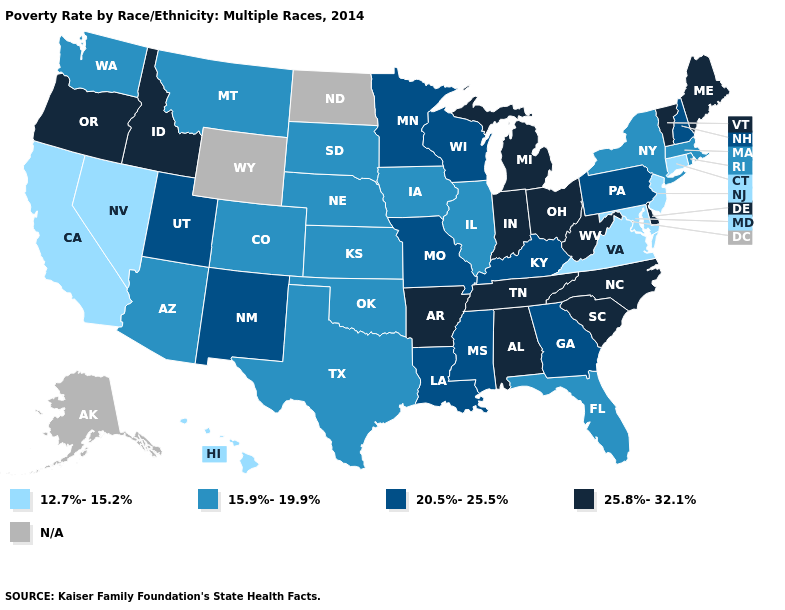Is the legend a continuous bar?
Quick response, please. No. Which states have the lowest value in the USA?
Quick response, please. California, Connecticut, Hawaii, Maryland, Nevada, New Jersey, Virginia. Name the states that have a value in the range 25.8%-32.1%?
Short answer required. Alabama, Arkansas, Delaware, Idaho, Indiana, Maine, Michigan, North Carolina, Ohio, Oregon, South Carolina, Tennessee, Vermont, West Virginia. Name the states that have a value in the range 12.7%-15.2%?
Keep it brief. California, Connecticut, Hawaii, Maryland, Nevada, New Jersey, Virginia. Does Texas have the highest value in the South?
Give a very brief answer. No. Does Oregon have the highest value in the USA?
Quick response, please. Yes. What is the value of Ohio?
Short answer required. 25.8%-32.1%. Does the first symbol in the legend represent the smallest category?
Write a very short answer. Yes. What is the value of Georgia?
Be succinct. 20.5%-25.5%. Name the states that have a value in the range N/A?
Keep it brief. Alaska, North Dakota, Wyoming. Among the states that border Connecticut , which have the lowest value?
Write a very short answer. Massachusetts, New York, Rhode Island. Name the states that have a value in the range 25.8%-32.1%?
Concise answer only. Alabama, Arkansas, Delaware, Idaho, Indiana, Maine, Michigan, North Carolina, Ohio, Oregon, South Carolina, Tennessee, Vermont, West Virginia. Which states hav the highest value in the Northeast?
Keep it brief. Maine, Vermont. Among the states that border Washington , which have the highest value?
Give a very brief answer. Idaho, Oregon. 